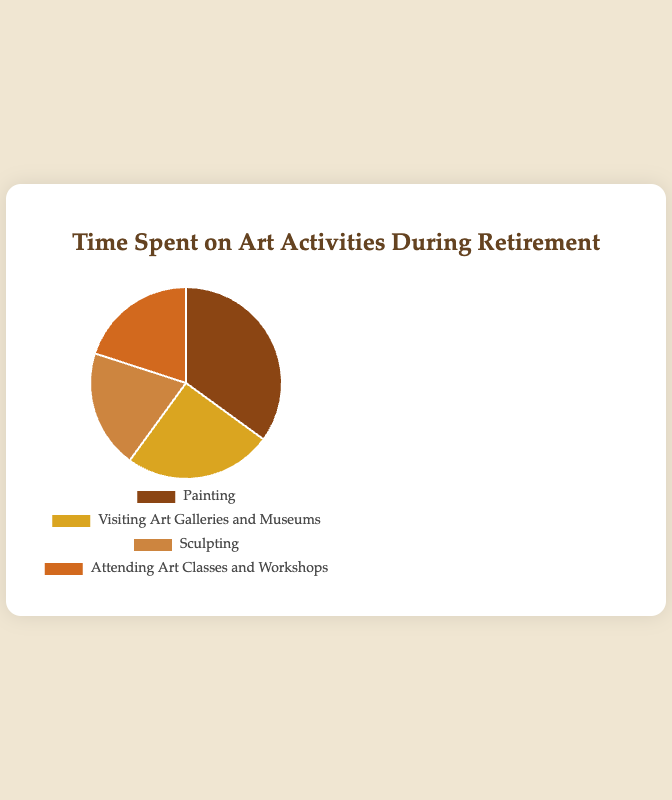How much more time is spent painting compared to sculpting? To find how much more time is spent painting compared to sculpting, subtract the percentage for sculpting (20%) from the percentage for painting (35%). Thus, 35% - 20% = 15%.
Answer: 15% How do the combined percentages for sculpting and attending art classes compare to the percentage for painting? Combine the percentages for sculpting (20%) and attending art classes (20%) to get 20% + 20% = 40%. Compare this with the percentage for painting (35%).
Answer: 40% is greater than 35% What's the smallest percentage value, and which activity does it correspond to? To find the smallest percentage value, refer to the four percentages. The smallest is 20% which corresponds to both sculpting and attending art classes and workshops.
Answer: 20%, sculpting and attending art classes and workshops What percentage of time is spent on activities other than painting? To find the percentage of time spent on activities other than painting, combine the percentages of all other activities: visiting art galleries (25%), sculpting (20%), and attending art classes (20%). Thus, 25% + 20% + 20% = 65%.
Answer: 65% Which activity is represented by the darkest color in the pie chart? Identify the darkest color by examining the given color list without the visualization. The brown shade (#8B4513), typically the darkest, is associated with painting.
Answer: Painting Which activities have an equal percentage of time spent? Look for percentages that are the same. Both sculpting and attending art classes and workshops have a percentage of 20%.
Answer: Sculpting and attending art classes and workshops What's the average time spent on visiting art galleries, sculpting, and attending art classes? Combine the percentages for visiting art galleries (25%), sculpting (20%), and attending art classes (20%) and then divide by 3. So, (25% + 20% + 20%) / 3 = 65% / 3 ≈ 21.67%.
Answer: 21.67% If the total time is represented by 360 degrees, what is the angle for visiting art galleries? Calculate the angle by taking 25% of 360 degrees. Thus, 0.25 * 360 = 90 degrees.
Answer: 90 degrees 